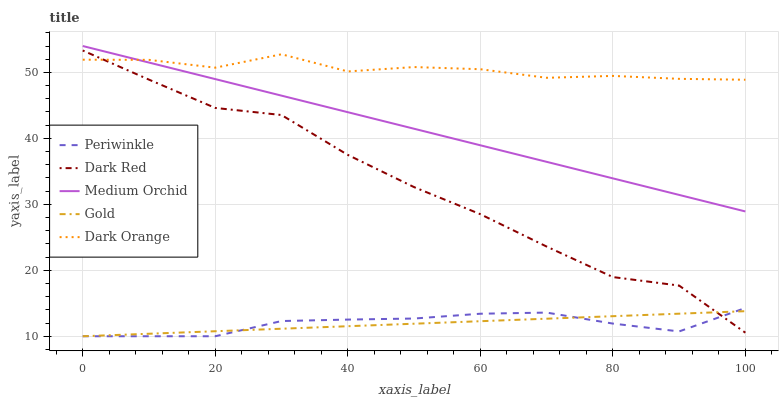Does Gold have the minimum area under the curve?
Answer yes or no. Yes. Does Dark Orange have the maximum area under the curve?
Answer yes or no. Yes. Does Medium Orchid have the minimum area under the curve?
Answer yes or no. No. Does Medium Orchid have the maximum area under the curve?
Answer yes or no. No. Is Medium Orchid the smoothest?
Answer yes or no. Yes. Is Dark Red the roughest?
Answer yes or no. Yes. Is Periwinkle the smoothest?
Answer yes or no. No. Is Periwinkle the roughest?
Answer yes or no. No. Does Periwinkle have the lowest value?
Answer yes or no. Yes. Does Medium Orchid have the lowest value?
Answer yes or no. No. Does Medium Orchid have the highest value?
Answer yes or no. Yes. Does Periwinkle have the highest value?
Answer yes or no. No. Is Dark Red less than Medium Orchid?
Answer yes or no. Yes. Is Medium Orchid greater than Dark Red?
Answer yes or no. Yes. Does Dark Red intersect Periwinkle?
Answer yes or no. Yes. Is Dark Red less than Periwinkle?
Answer yes or no. No. Is Dark Red greater than Periwinkle?
Answer yes or no. No. Does Dark Red intersect Medium Orchid?
Answer yes or no. No. 